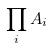Convert formula to latex. <formula><loc_0><loc_0><loc_500><loc_500>\prod _ { i } A _ { i }</formula> 